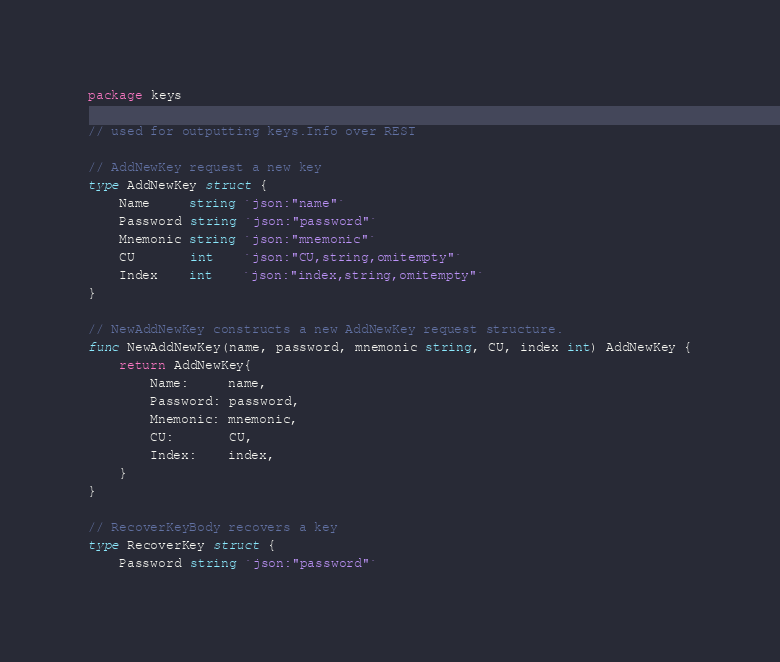<code> <loc_0><loc_0><loc_500><loc_500><_Go_>package keys

// used for outputting keys.Info over REST

// AddNewKey request a new key
type AddNewKey struct {
	Name     string `json:"name"`
	Password string `json:"password"`
	Mnemonic string `json:"mnemonic"`
	CU       int    `json:"CU,string,omitempty"`
	Index    int    `json:"index,string,omitempty"`
}

// NewAddNewKey constructs a new AddNewKey request structure.
func NewAddNewKey(name, password, mnemonic string, CU, index int) AddNewKey {
	return AddNewKey{
		Name:     name,
		Password: password,
		Mnemonic: mnemonic,
		CU:       CU,
		Index:    index,
	}
}

// RecoverKeyBody recovers a key
type RecoverKey struct {
	Password string `json:"password"`</code> 